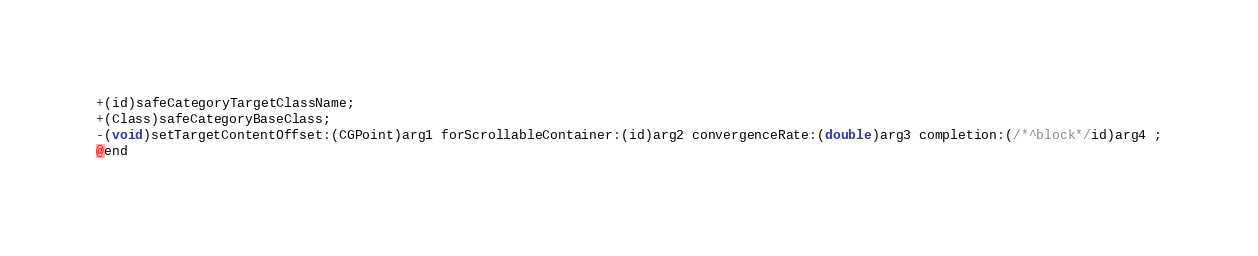Convert code to text. <code><loc_0><loc_0><loc_500><loc_500><_C_>+(id)safeCategoryTargetClassName;
+(Class)safeCategoryBaseClass;
-(void)setTargetContentOffset:(CGPoint)arg1 forScrollableContainer:(id)arg2 convergenceRate:(double)arg3 completion:(/*^block*/id)arg4 ;
@end

</code> 